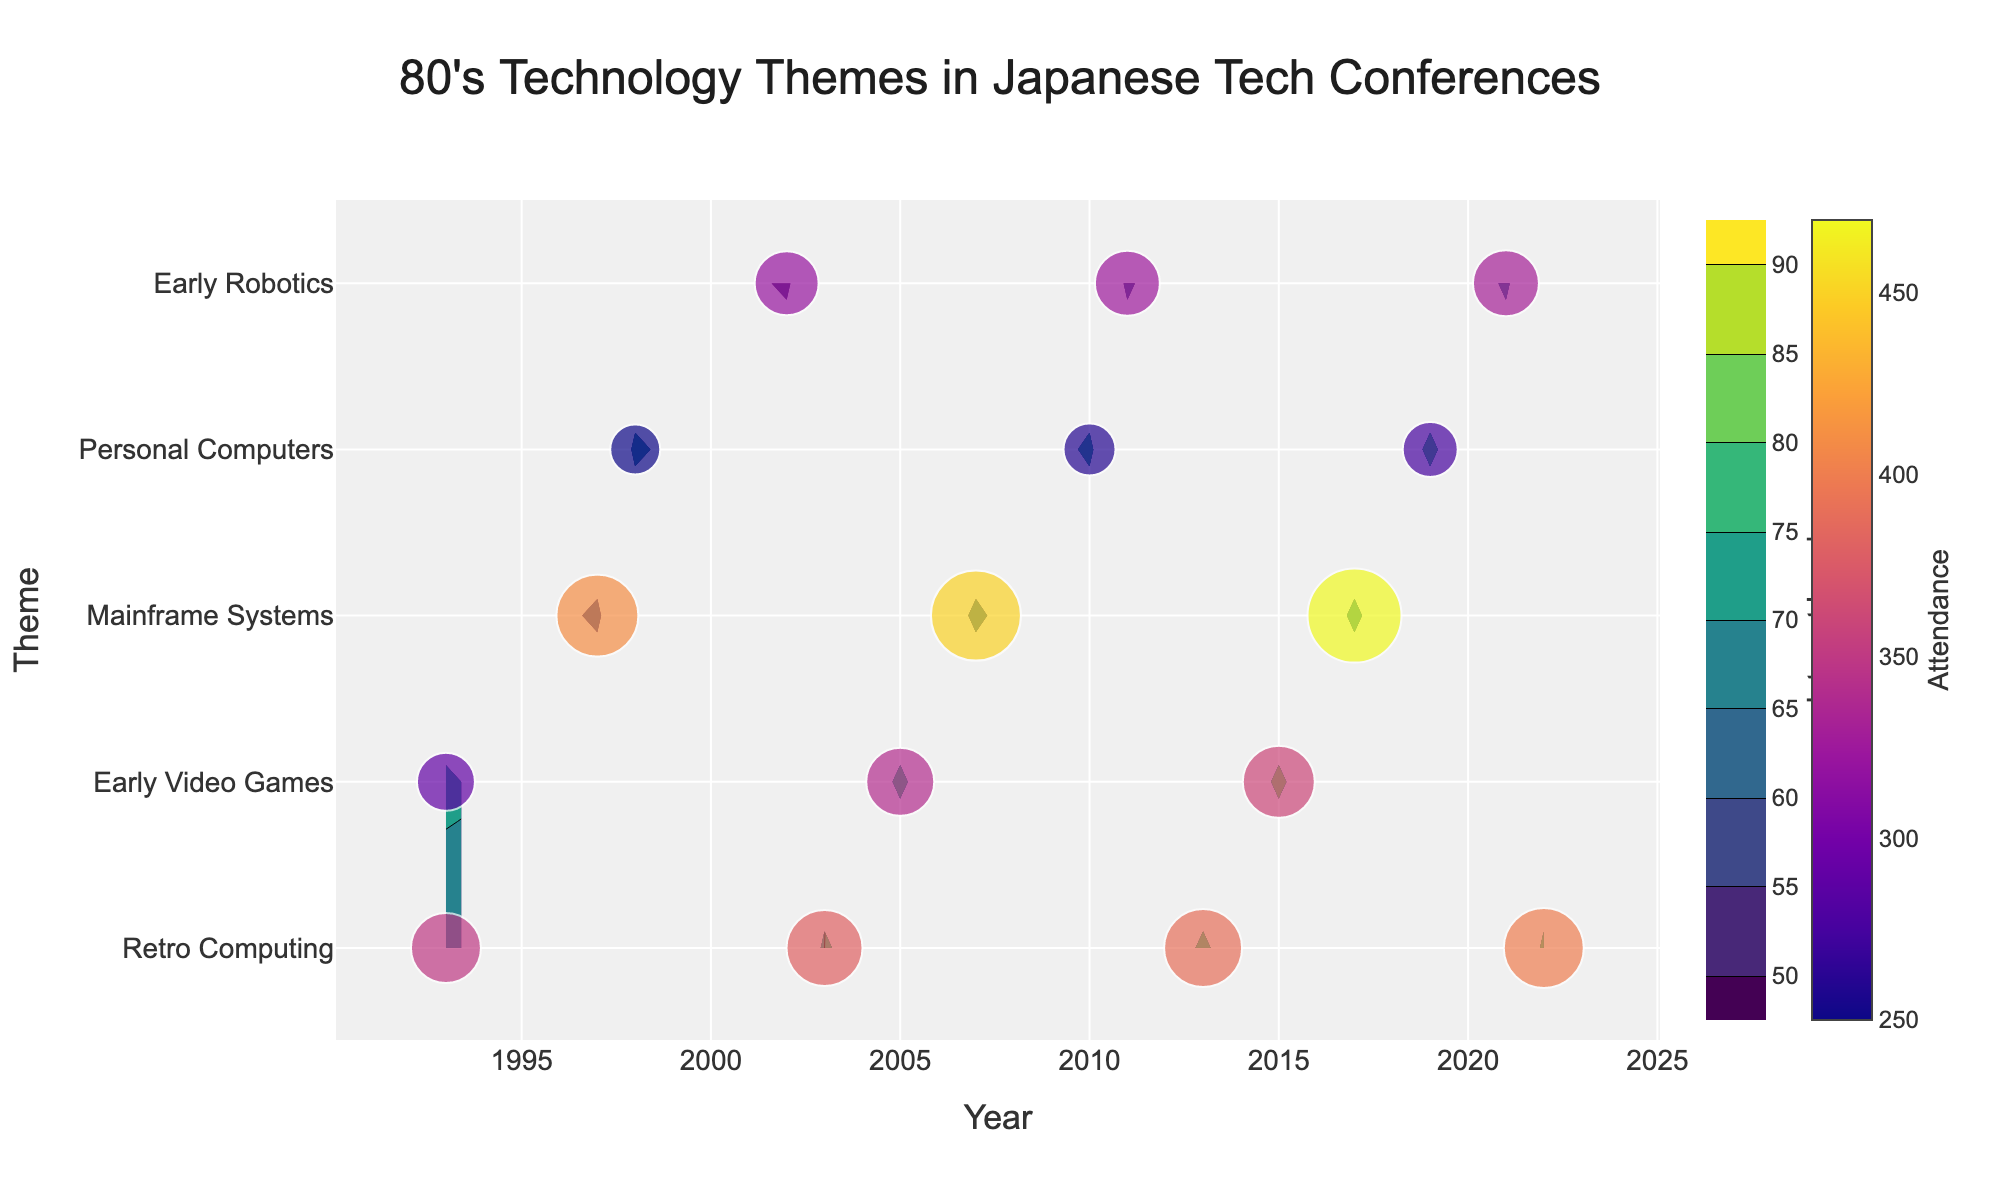What is the title of the figure? The title of the figure is located at the top center and often summarizes what the plot is about. In this case, it reads "80's Technology Themes in Japanese Tech Conferences".
Answer: "80's Technology Themes in Japanese Tech Conferences" What is the color scale used for the contour plot? The color scale is indicated in the plot description, showing a gradient ranging from darker colors to lighter colors. Here, the colorscale 'Viridis' is used, which typically includes shades from dark blue to yellow.
Answer: Viridis Which technology theme had the highest interest level in 2022? By looking at the labels along the contour plot and the corresponding contour levels for the year 2022, we can identify the highest interest level. The theme "Retro Computing" has the highest level.
Answer: Retro Computing How does the attendance at KyotoTechTalks change over time? To determine this, find all the attendance values associated with "KyotoTechTalks" theme across different years and compare them. We have 250 in 1998, 260 in 2010, and 275 in 2019, showing an increasing trend over time.
Answer: It increases What happens to the interest level in "Early Video Games" from 1993 to 2015? By inspecting the contour plot lines for "Early Video Games" from 1993 to 2015, we see that the interest level starts at 72 in 1993 and then increases to 85 by 2015.
Answer: It increases Which year had the highest attendance overall? To answer this, we need to look at all the scatter plot marker sizes or colors that represent attendance and identify the largest one. The year with the largest attendance is 2017 with 470 attendees at TokyoSoftExpo.
Answer: 2017 What is the average interest level for "Retro Computing" across all available years? Find the interest levels for "Retro Computing" across 1993, 2003, 2013, and 2022, then calculate their average: (65 + 75 + 78 + 80) / 4 = 74.5
Answer: 74.5 Compare the trends in interest level for "Mainframe Systems" and "Personal Computers" over time. Observing the contour plot lines, "Mainframe Systems" shows minor fluctuations but generally increases from 58 in 1997 to 68 in 2017. "Personal Computers" shows a consistent increase from 68 in 1998 to 77 in 2019.
Answer: Both increase over time, but "Personal Computers" shows a steadier increase What trend do you notice in the interest level for "Early Robotics" from the dataset? By analyzing the contour plot, "Early Robotics" shows interest levels of 54 in 2002, 59 in 2011, and 61 in 2021, which depicts a gradually increasing trend.
Answer: It increases gradually Which years had an attendance that is larger than 300 for the "JapanTech17" conferences? Look at the scatter plot markers for "JapanTech17" (attendances): 1993 (350 attendees), 2003 (380), 2013 (390), and 2022 (400). All these years had an attendance larger than 300.
Answer: 1993, 2003, 2013, 2022 